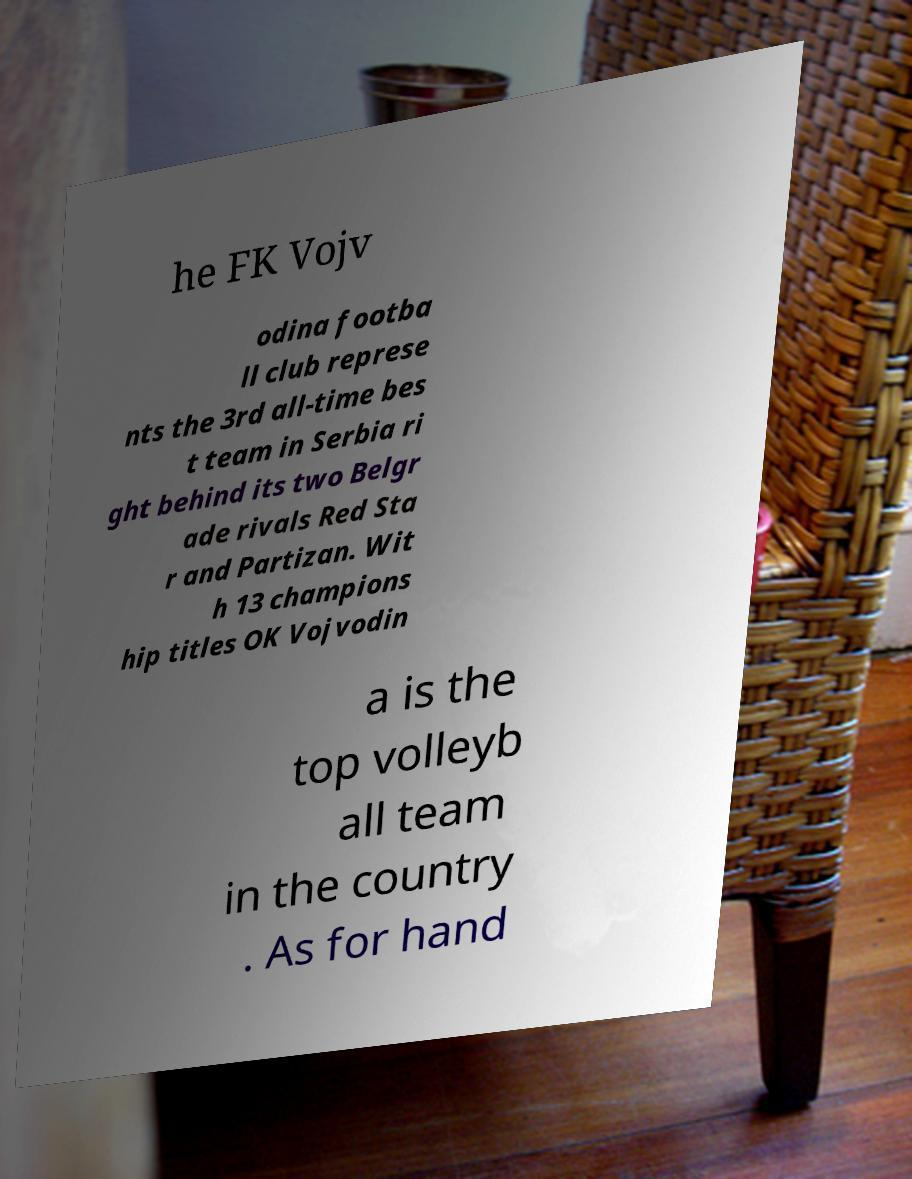Can you read and provide the text displayed in the image?This photo seems to have some interesting text. Can you extract and type it out for me? he FK Vojv odina footba ll club represe nts the 3rd all-time bes t team in Serbia ri ght behind its two Belgr ade rivals Red Sta r and Partizan. Wit h 13 champions hip titles OK Vojvodin a is the top volleyb all team in the country . As for hand 